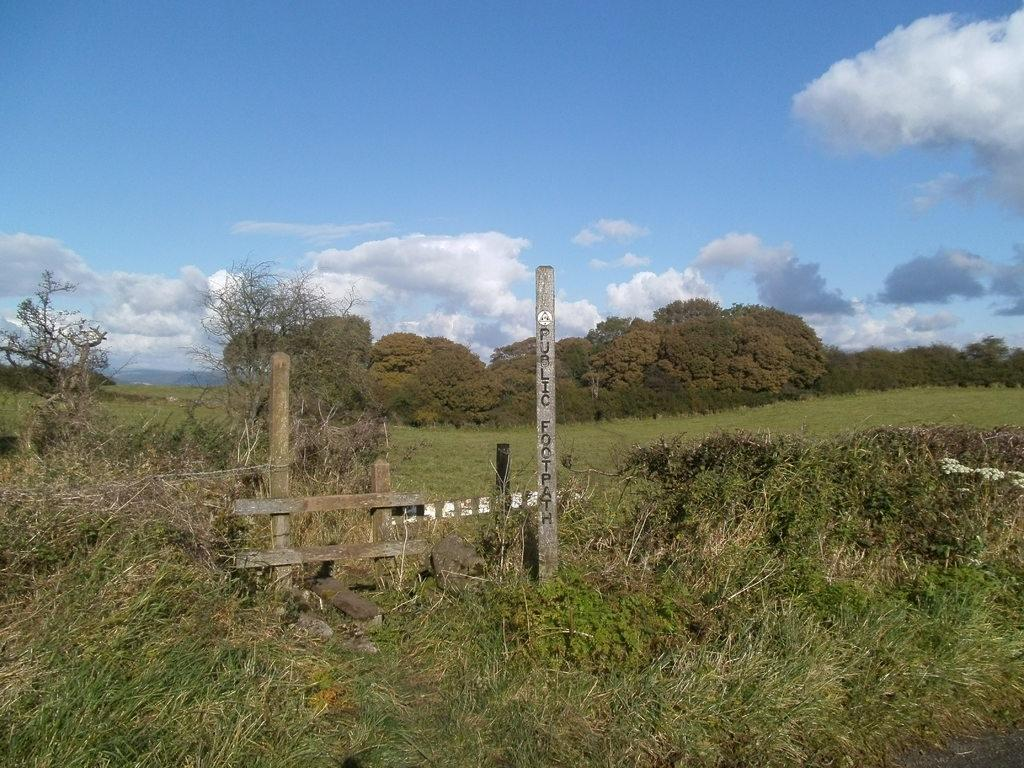What is the black color text on in the image? There is a pole with black color text in the image. What type of vegetation is present in the image? There is grass in the image, and many trees can also be seen. What is visible at the top of the image? The sky is visible at the top of the image. What can be seen in the sky? There are clouds in the sky. What type of flame can be seen near the trees in the image? There is no flame present in the image. 